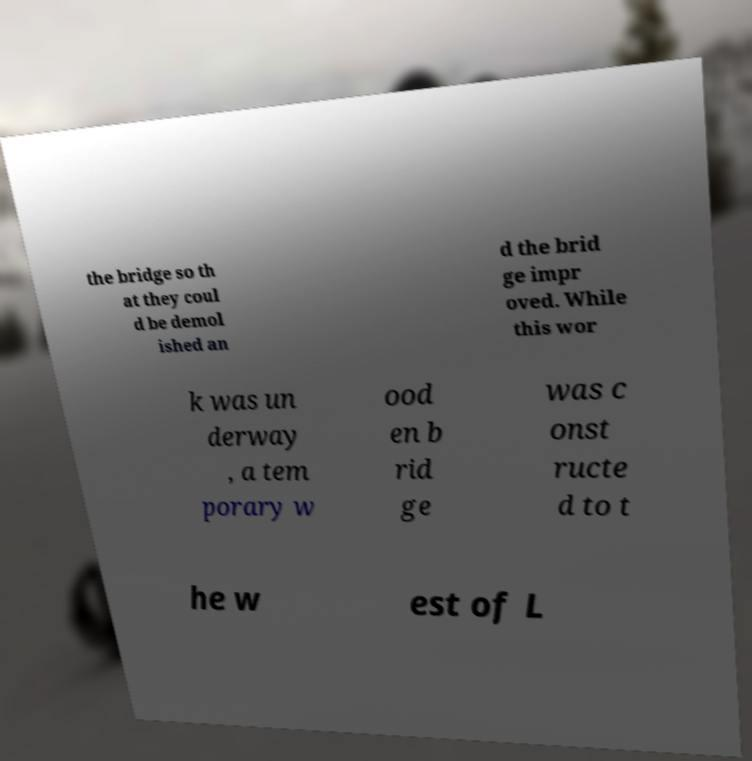Can you read and provide the text displayed in the image?This photo seems to have some interesting text. Can you extract and type it out for me? the bridge so th at they coul d be demol ished an d the brid ge impr oved. While this wor k was un derway , a tem porary w ood en b rid ge was c onst ructe d to t he w est of L 